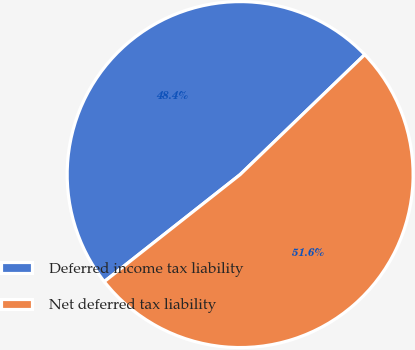Convert chart to OTSL. <chart><loc_0><loc_0><loc_500><loc_500><pie_chart><fcel>Deferred income tax liability<fcel>Net deferred tax liability<nl><fcel>48.42%<fcel>51.58%<nl></chart> 